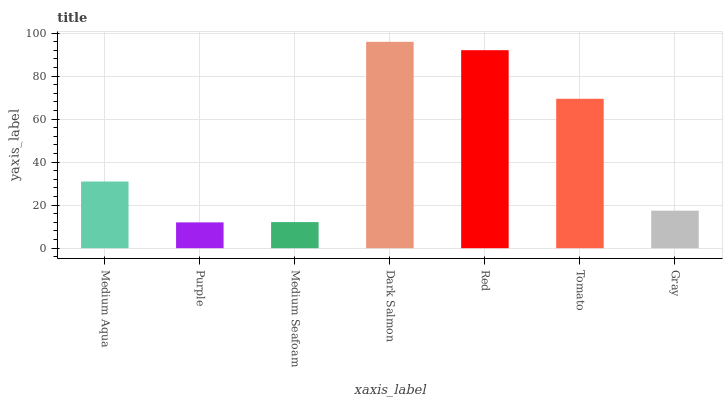Is Purple the minimum?
Answer yes or no. Yes. Is Dark Salmon the maximum?
Answer yes or no. Yes. Is Medium Seafoam the minimum?
Answer yes or no. No. Is Medium Seafoam the maximum?
Answer yes or no. No. Is Medium Seafoam greater than Purple?
Answer yes or no. Yes. Is Purple less than Medium Seafoam?
Answer yes or no. Yes. Is Purple greater than Medium Seafoam?
Answer yes or no. No. Is Medium Seafoam less than Purple?
Answer yes or no. No. Is Medium Aqua the high median?
Answer yes or no. Yes. Is Medium Aqua the low median?
Answer yes or no. Yes. Is Gray the high median?
Answer yes or no. No. Is Gray the low median?
Answer yes or no. No. 